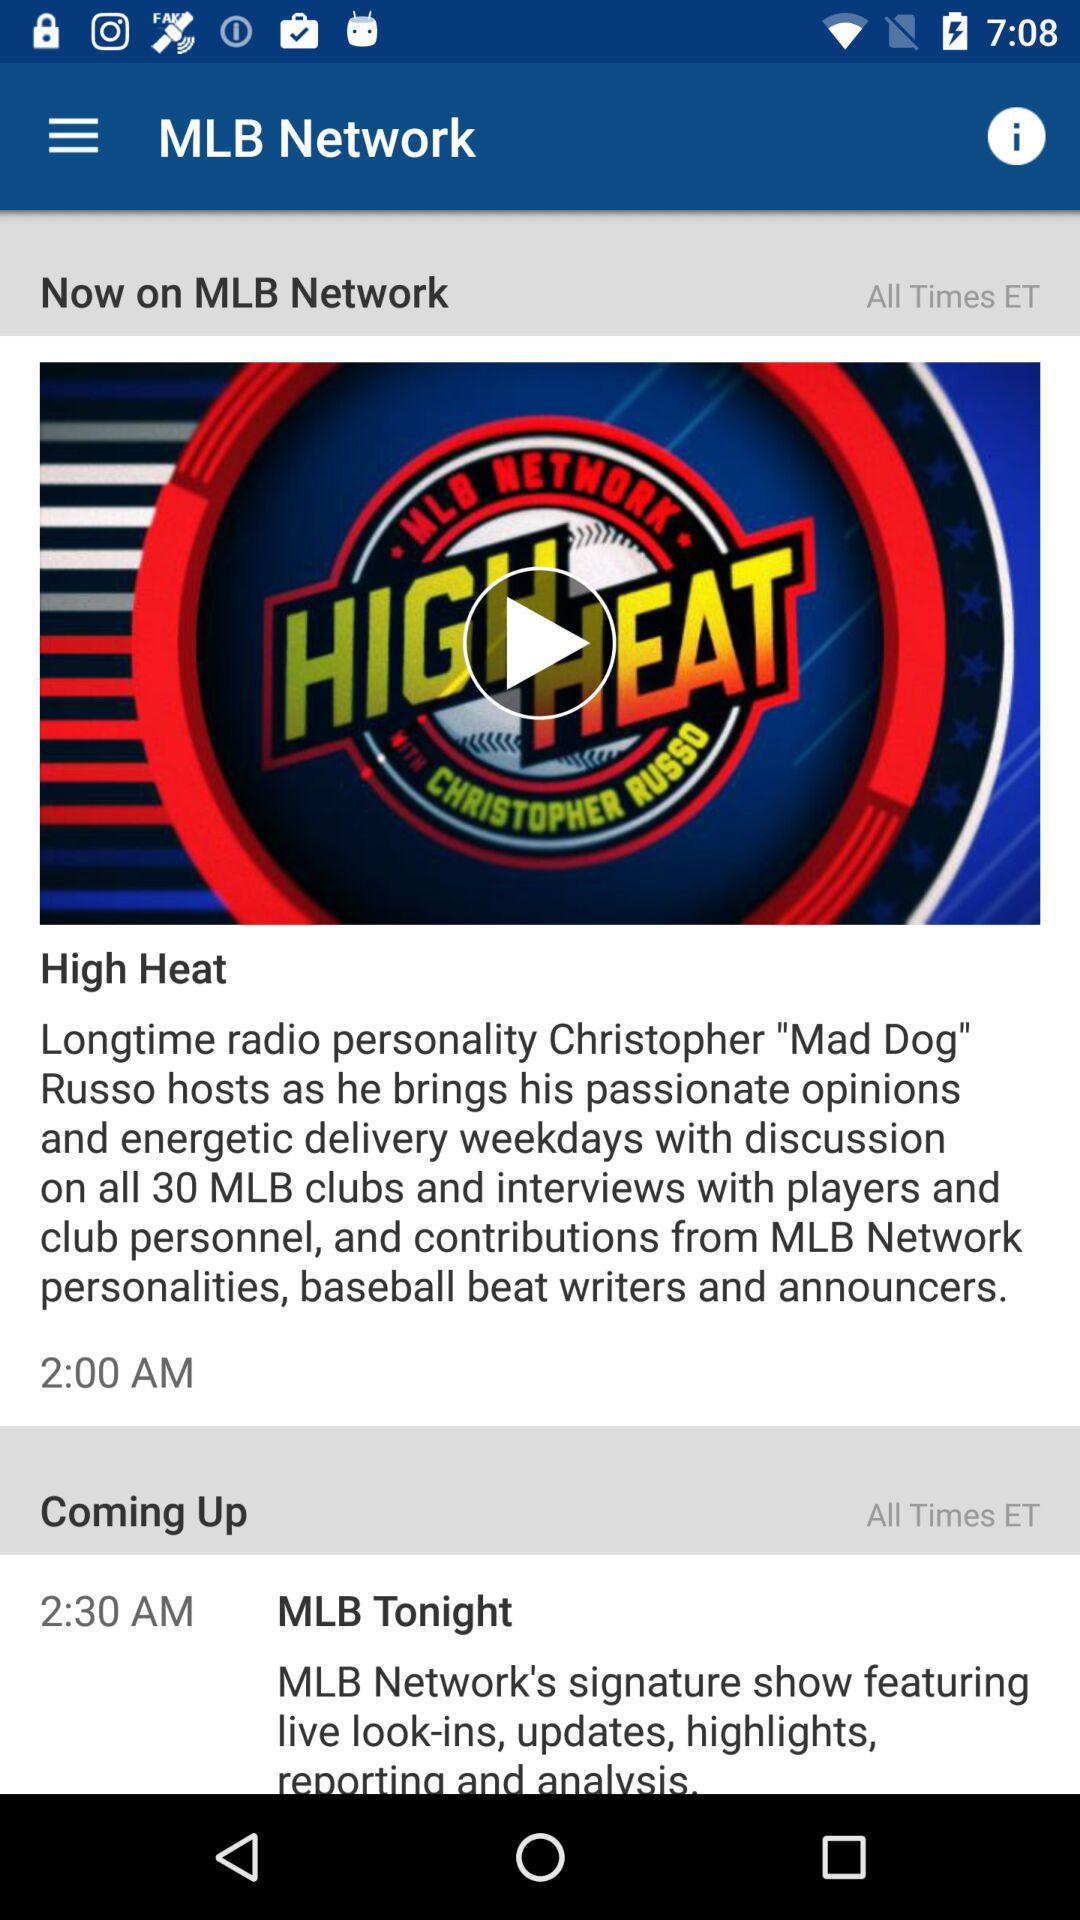What is the show name? The names of the shows are "High Heat" and "MLB Tonight". 